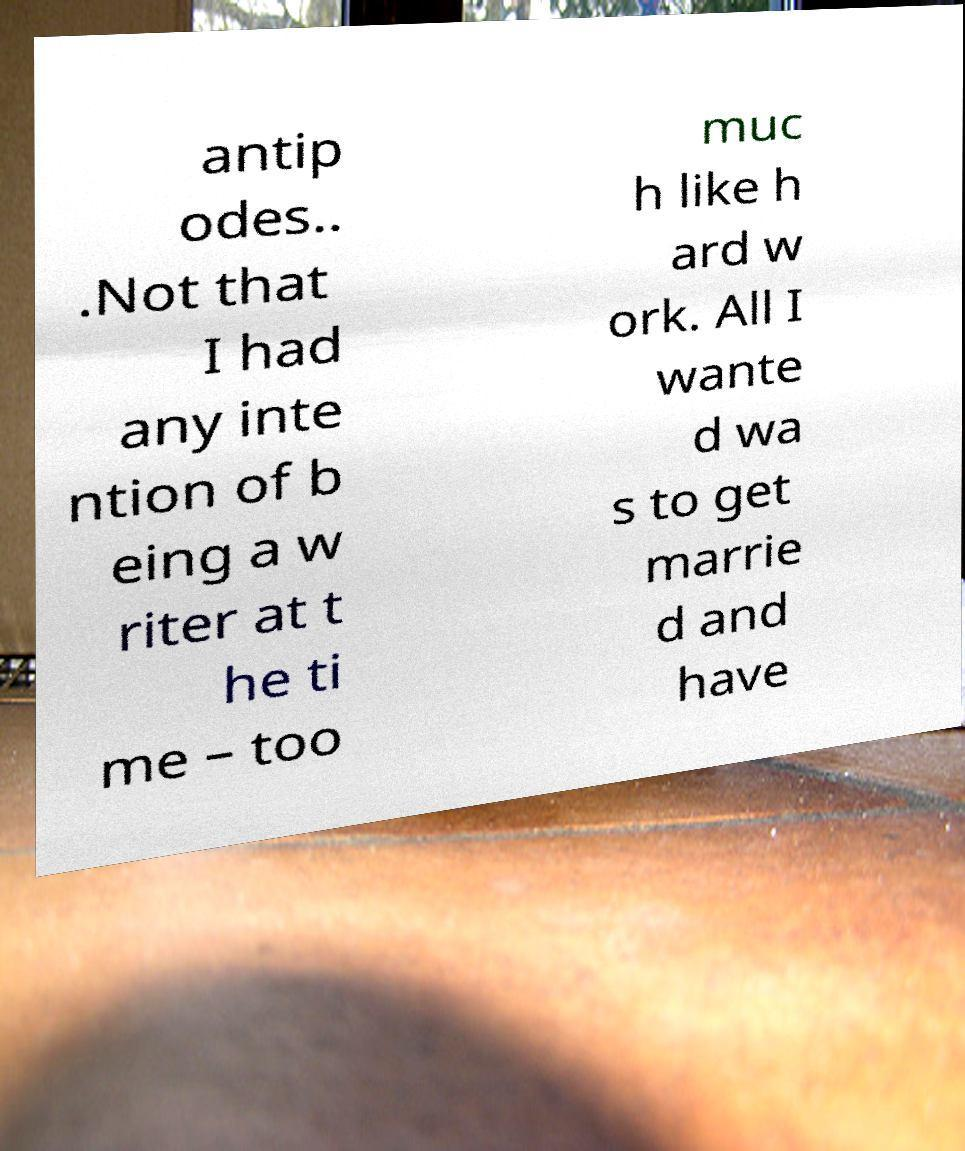Can you accurately transcribe the text from the provided image for me? antip odes.. .Not that I had any inte ntion of b eing a w riter at t he ti me – too muc h like h ard w ork. All I wante d wa s to get marrie d and have 